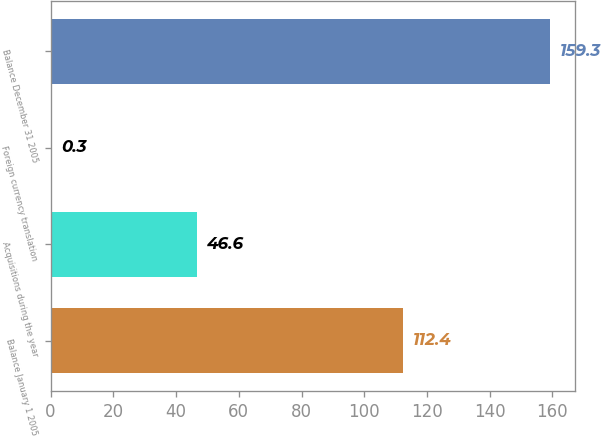<chart> <loc_0><loc_0><loc_500><loc_500><bar_chart><fcel>Balance January 1 2005<fcel>Acquisitions during the year<fcel>Foreign currency translation<fcel>Balance December 31 2005<nl><fcel>112.4<fcel>46.6<fcel>0.3<fcel>159.3<nl></chart> 